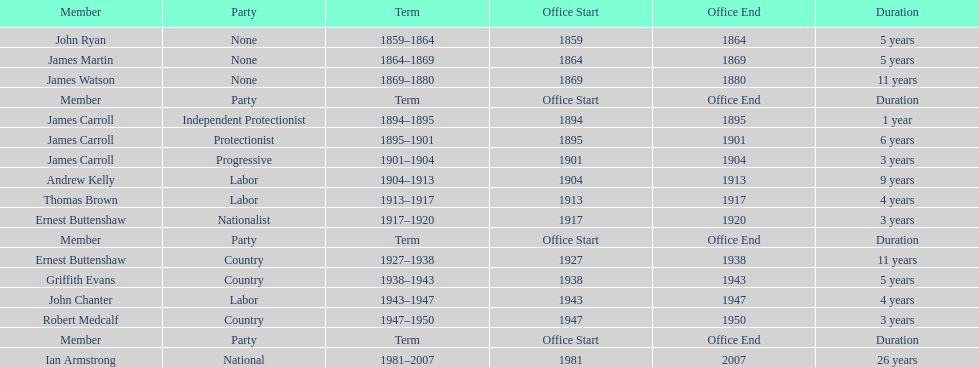How many years of service do the members of the second incarnation have combined? 26. 